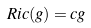<formula> <loc_0><loc_0><loc_500><loc_500>R i c ( g ) = c g</formula> 